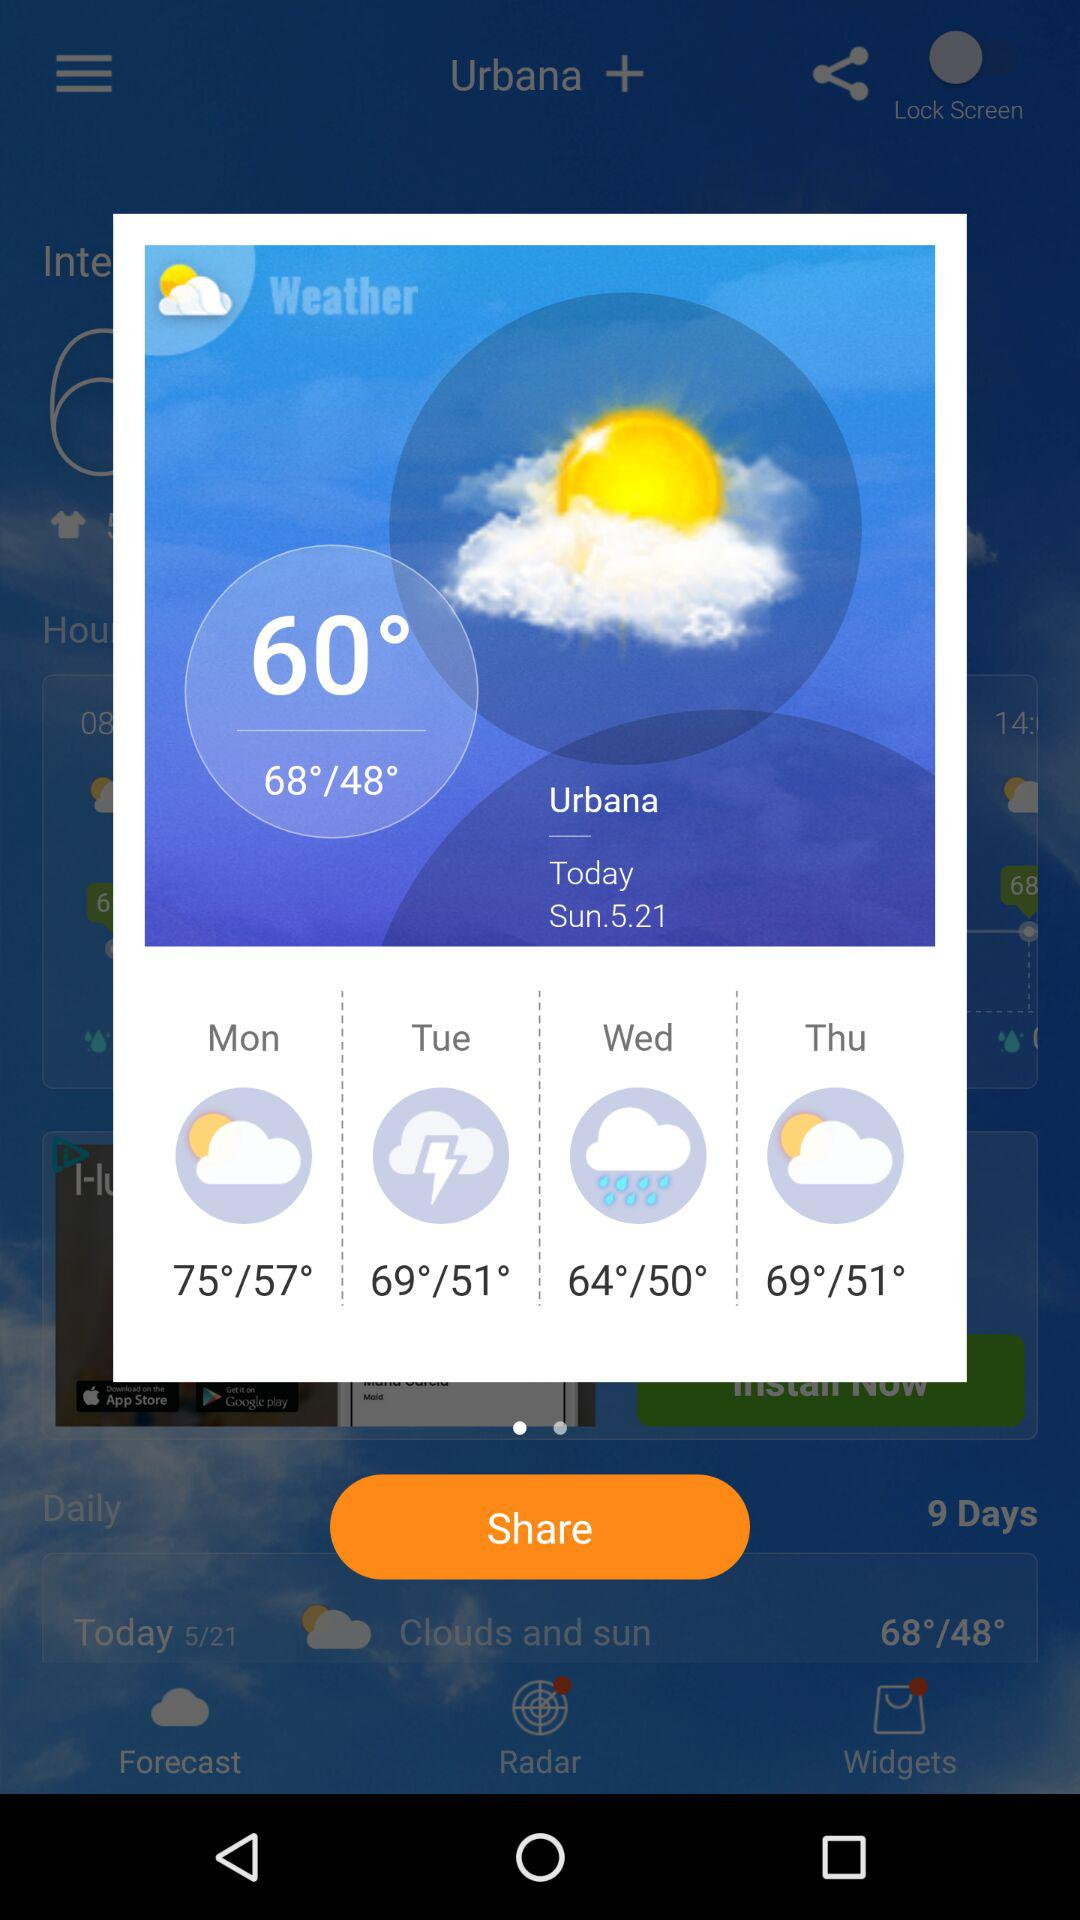What is the temperature on Monday? The temperature on Monday is 75°/57°. 